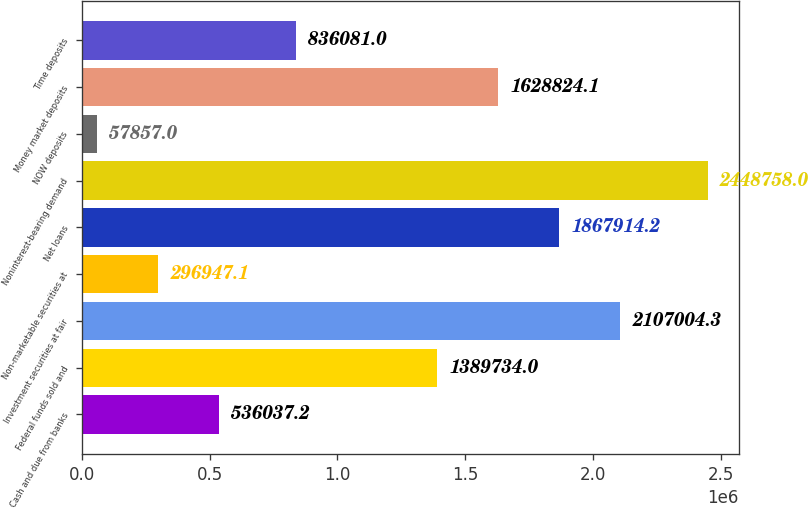<chart> <loc_0><loc_0><loc_500><loc_500><bar_chart><fcel>Cash and due from banks<fcel>Federal funds sold and<fcel>Investment securities at fair<fcel>Non-marketable securities at<fcel>Net loans<fcel>Noninterest-bearing demand<fcel>NOW deposits<fcel>Money market deposits<fcel>Time deposits<nl><fcel>536037<fcel>1.38973e+06<fcel>2.107e+06<fcel>296947<fcel>1.86791e+06<fcel>2.44876e+06<fcel>57857<fcel>1.62882e+06<fcel>836081<nl></chart> 